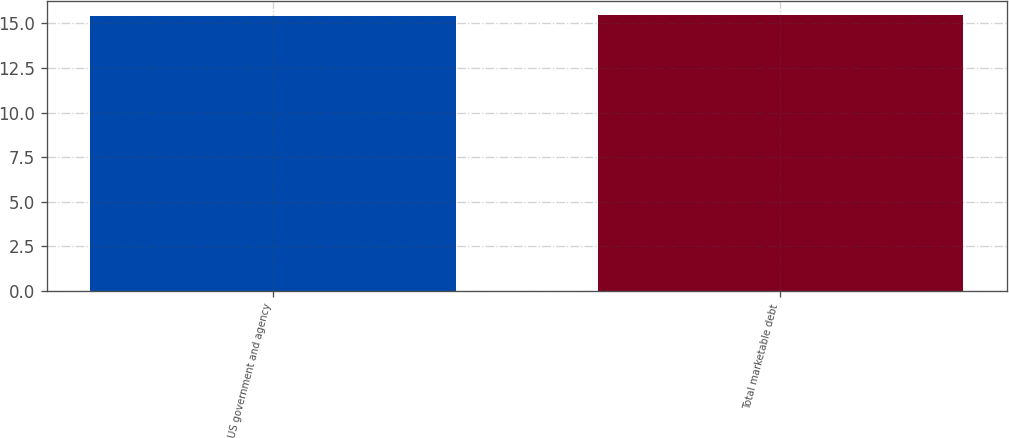<chart> <loc_0><loc_0><loc_500><loc_500><bar_chart><fcel>US government and agency<fcel>Total marketable debt<nl><fcel>15.4<fcel>15.5<nl></chart> 